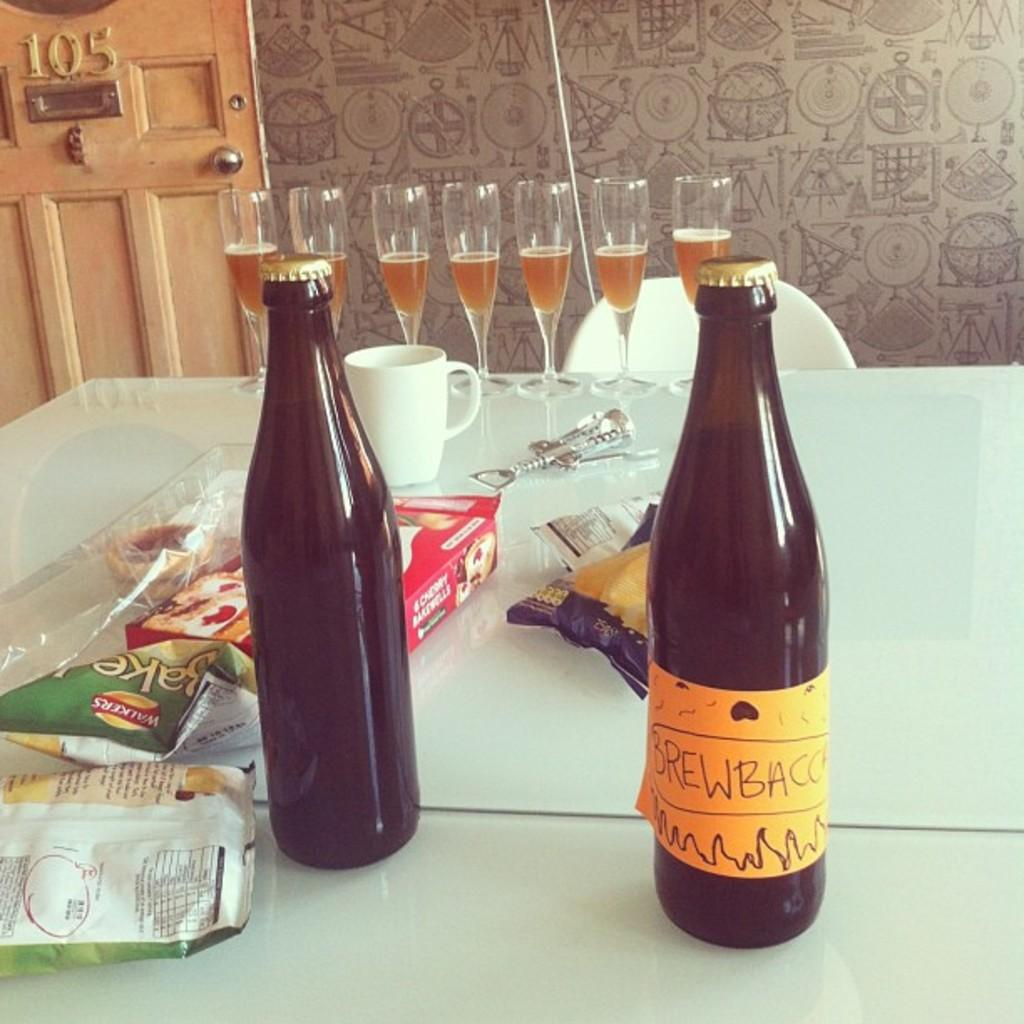<image>
Describe the image concisely. Two brown bottles labeled Brewbacc are on a table by a row of champagne glasses. 